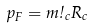<formula> <loc_0><loc_0><loc_500><loc_500>p _ { F } = m \omega _ { c } R _ { c }</formula> 